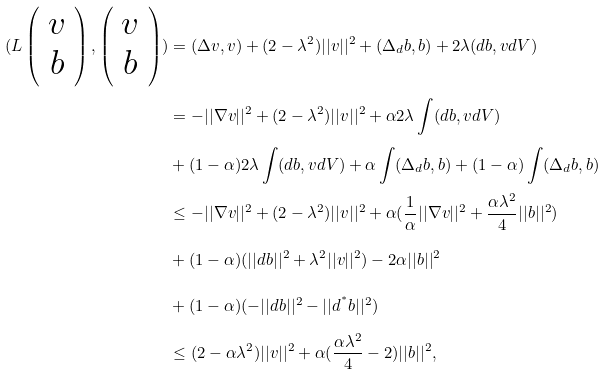Convert formula to latex. <formula><loc_0><loc_0><loc_500><loc_500>( L \left ( \begin{array} { c } v \\ b \end{array} \right ) , \left ( \begin{array} { c } v \\ b \end{array} \right ) ) & = ( \Delta v , v ) + ( 2 - \lambda ^ { 2 } ) | | v | | ^ { 2 } + ( \Delta _ { d } b , b ) + 2 \lambda ( d b , v d V ) \\ & = - | | \nabla v | | ^ { 2 } + ( 2 - \lambda ^ { 2 } ) | | v | | ^ { 2 } + \alpha 2 \lambda \int ( d b , v d V ) \\ & + ( 1 - \alpha ) 2 \lambda \int ( d b , v d V ) + \alpha \int ( \Delta _ { d } b , b ) + ( 1 - \alpha ) \int ( \Delta _ { d } b , b ) \\ & \leq - | | \nabla v | | ^ { 2 } + ( 2 - \lambda ^ { 2 } ) | | v | | ^ { 2 } + \alpha ( \frac { 1 } { \alpha } | | \nabla v | | ^ { 2 } + \frac { \alpha \lambda ^ { 2 } } { 4 } | | b | | ^ { 2 } ) \\ & + ( 1 - \alpha ) ( | | d b | | ^ { 2 } + \lambda ^ { 2 } | | v | | ^ { 2 } ) - 2 \alpha | | b | | ^ { 2 } \\ & + ( 1 - \alpha ) ( - | | d b | | ^ { 2 } - | | d ^ { ^ { * } } b | | ^ { 2 } ) \\ & \leq ( 2 - \alpha \lambda ^ { 2 } ) | | v | | ^ { 2 } + \alpha ( \frac { \alpha \lambda ^ { 2 } } { 4 } - 2 ) | | b | | ^ { 2 } ,</formula> 